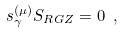Convert formula to latex. <formula><loc_0><loc_0><loc_500><loc_500>s _ { \gamma } ^ { ( \mu ) } S _ { R G Z } = 0 \ ,</formula> 